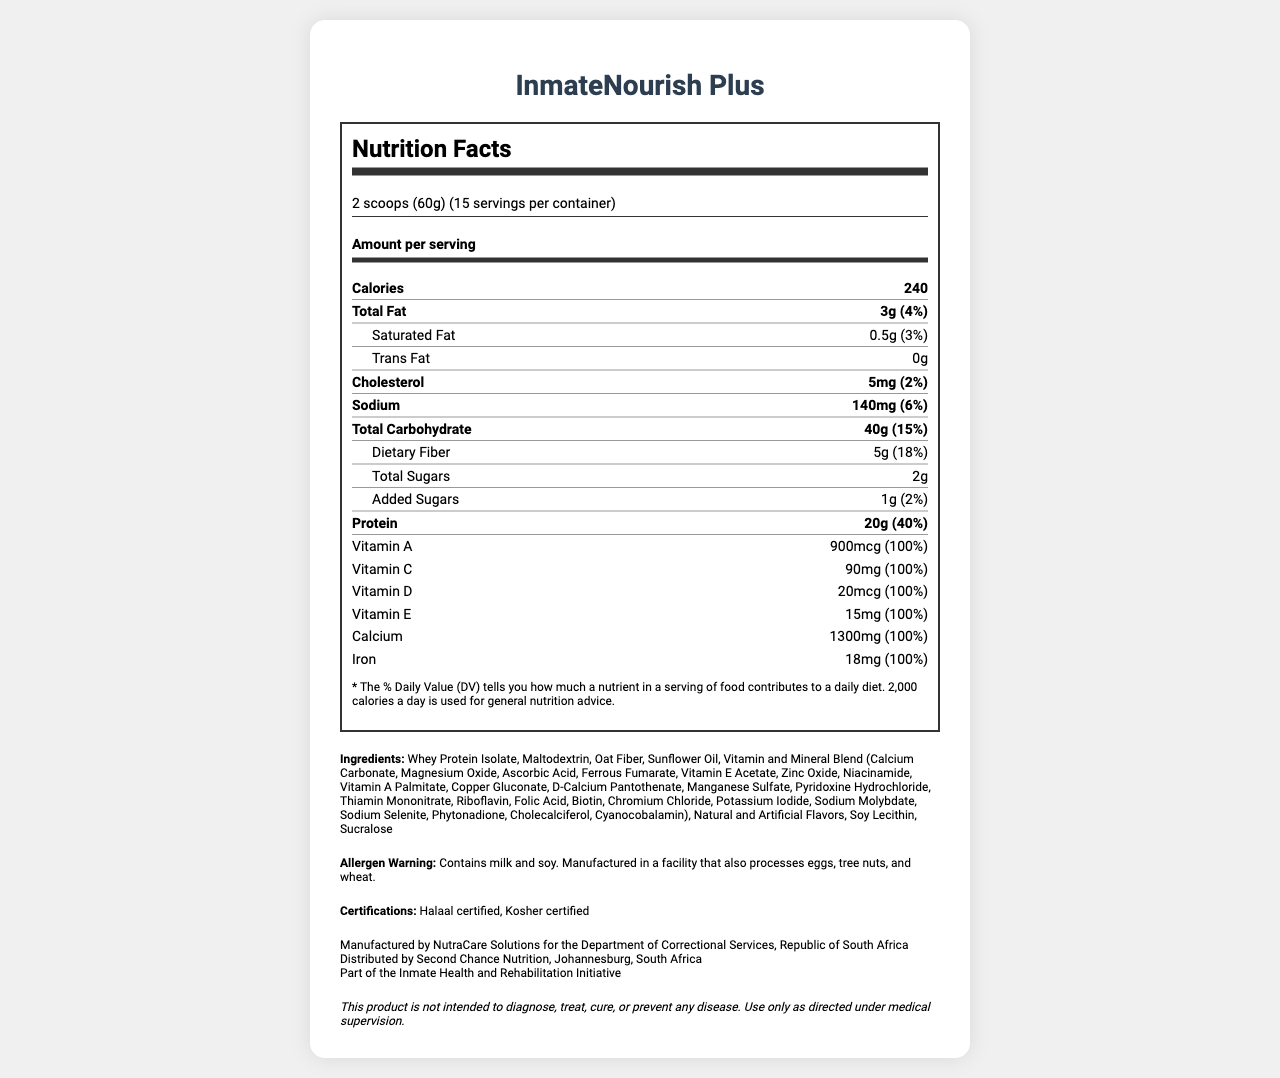what is the serving size of InmateNourish Plus? The serving size is clearly stated under the heading that indicates serving information.
Answer: 2 scoops (60g) how many servings are there per container? This information is given in the serving information section near the top of the label.
Answer: 15 how many calories are in one serving of InmateNourish Plus? The calories per serving are listed prominently under the "Amount per serving" section.
Answer: 240 what is the amount of protein per serving? The protein content is listed under the nutrition facts in the main nutrient rows.
Answer: 20g how much dietary fiber does a serving provide? The dietary fiber content is listed under the "Total Carbohydrate" section.
Answer: 5g what is the % Daily Value of Vitamin C in one serving of the supplement? The % Daily Value for Vitamin C is provided in the list of vitamins and minerals.
Answer: 100% which of the following is NOT an ingredient in InmateNourish Plus? A. Maltodextrin B. Oat Fiber C. Coconut Oil D. Sucralose All listed ingredients except Coconut Oil are in the ingredient list.
Answer: C. Coconut Oil how many grams of total fat are in one serving of InmateNourish Plus? The total fat content per serving is given in the main nutrient row under Total Fat.
Answer: 3g does this supplement contain any allergens? The allergen warning indicates it contains milk and soy and is manufactured in a facility that processes additional allergens.
Answer: Yes what is the main objective of the InmateNourish Plus project? This information is provided towards the end of the document under the manufacturer and distributor information.
Answer: Part of the Inmate Health and Rehabilitation Initiative which company manufactures InmateNourish Plus? A. Second Chance Nutrition B. NutraCare Solutions C. Department of Correctional Services D. HealthPlus Corp The manufacturer is NutraCare Solutions, as mentioned under manufacturer information.
Answer: B. NutraCare Solutions can this supplement diagnose or cure diseases? The disclaimer at the end explicitly states that the product is not intended to diagnose, treat, cure, or prevent any disease.
Answer: No summarize the main details provided in the Nutrition Facts Label for InmateNourish Plus. The label contains detailed nutrition information, ingredient list, allergen warnings, certifications, and manufacturer details, structured to inform about the product's health benefits and constraints.
Answer: The Nutrition Facts Label of InmateNourish Plus provides comprehensive nutritional information, including calories, macronutrients (proteins, fats, carbohydrates), vitamins, and minerals. It details the serving size, number of servings per container, and percentages of Daily Value for various nutrients. Additionally, it lists the ingredients, contains allergen warnings, certifications, manufacturer and distributor information, and a disclaimer. The supplement is part of the Inmate Health and Rehabilitation Initiative. what specific benefits does the added vitamin and mineral blend offer? The label lists the vitamins and minerals included but does not provide specific benefits or descriptions for each component.
Answer: Not enough information 